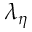<formula> <loc_0><loc_0><loc_500><loc_500>\lambda _ { \eta }</formula> 